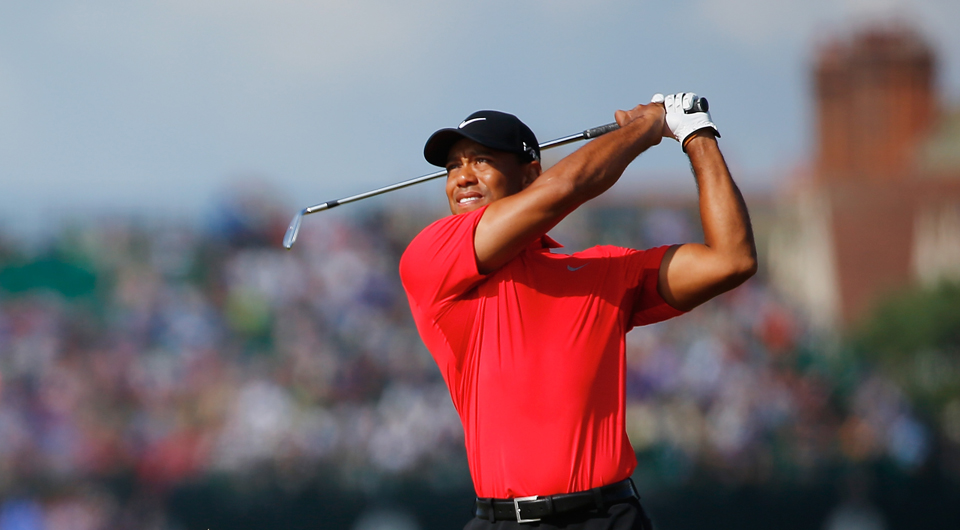Write a poetic description inspired by this image. In a sea of faces blurred by the fervor of the game,
A figure stands poised, in red, a beacon of fame.
The swing, a ballet of precision and grace,
Every movement calculated, at the perfect pace.
The crowd, a tapestry of dreams entwined,
Each cheer a tribute to the talent refined.
In silence and breath, in awe, they share,
A moment suspended in the crisp morning air.
Here on the green, where legends are told,
A story unfolds with each stroke of the bold. 